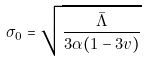<formula> <loc_0><loc_0><loc_500><loc_500>\sigma _ { 0 } = \sqrt { \frac { \bar { \Lambda } } { 3 \alpha ( 1 - 3 v ) } }</formula> 